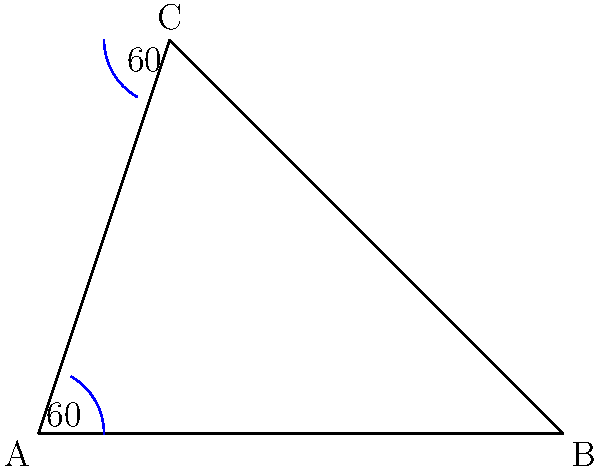In the context of promoting computer science education, consider the following diagram demonstrating the Angle-Side-Angle (ASA) congruence theorem. If triangle ABC has two angles of $60°$ each and the side between them is 4 units long, what is the measure of the third angle? To solve this problem, we'll use the properties of triangles and the ASA congruence theorem:

1. Recall that the sum of angles in any triangle is always $180°$.

2. We are given two angles in the triangle, each measuring $60°$.

3. Let's call the third angle $x°$.

4. We can set up an equation:
   $60° + 60° + x° = 180°$

5. Simplify:
   $120° + x° = 180°$

6. Subtract $120°$ from both sides:
   $x° = 180° - 120° = 60°$

Therefore, the measure of the third angle is also $60°$.

This example demonstrates how geometric principles, which are fundamental to many computer science applications like computer graphics and computational geometry, can be taught and understood using interactive diagrams.
Answer: $60°$ 